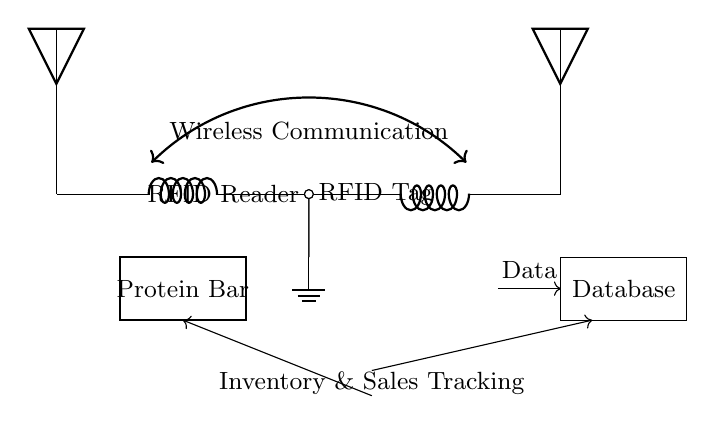what component represents the RFID Tag? The RFID Tag is represented by the small circle labeled "RFID Tag" in the circuit diagram, which is connected to an antenna.
Answer: RFID Tag what is the purpose of the wireless communication in the circuit? The wireless communication connects the RFID Tag to the RFID Reader, facilitating data transfer without physical connectors, shown as a double-headed arrow between the components.
Answer: Data transfer how many main components are there in the circuit? The main components are the RFID Tag, RFID Reader, and Database, totaling three essential parts displayed in the diagram.
Answer: Three what does the arrow between the inventory tracking and database indicate? The arrow signifies the flow of data from the inventory tracking system to the database, showing a connection that allows information transfer, which is crucial for managing inventory and sales.
Answer: Data flow what is the shape used to show the protein bar in the diagram? The protein bar is depicted as a rectangle, which indicates a physical object in the circuit, emphasizing its role in the context of inventory tracking.
Answer: Rectangle how does the RFID Reader communicate with the RFID Tag? The RFID Reader communicates with the RFID Tag through radio waves, represented by the wireless communication label in the circuit, illustrating a non-contact method of reading data.
Answer: Radio waves 